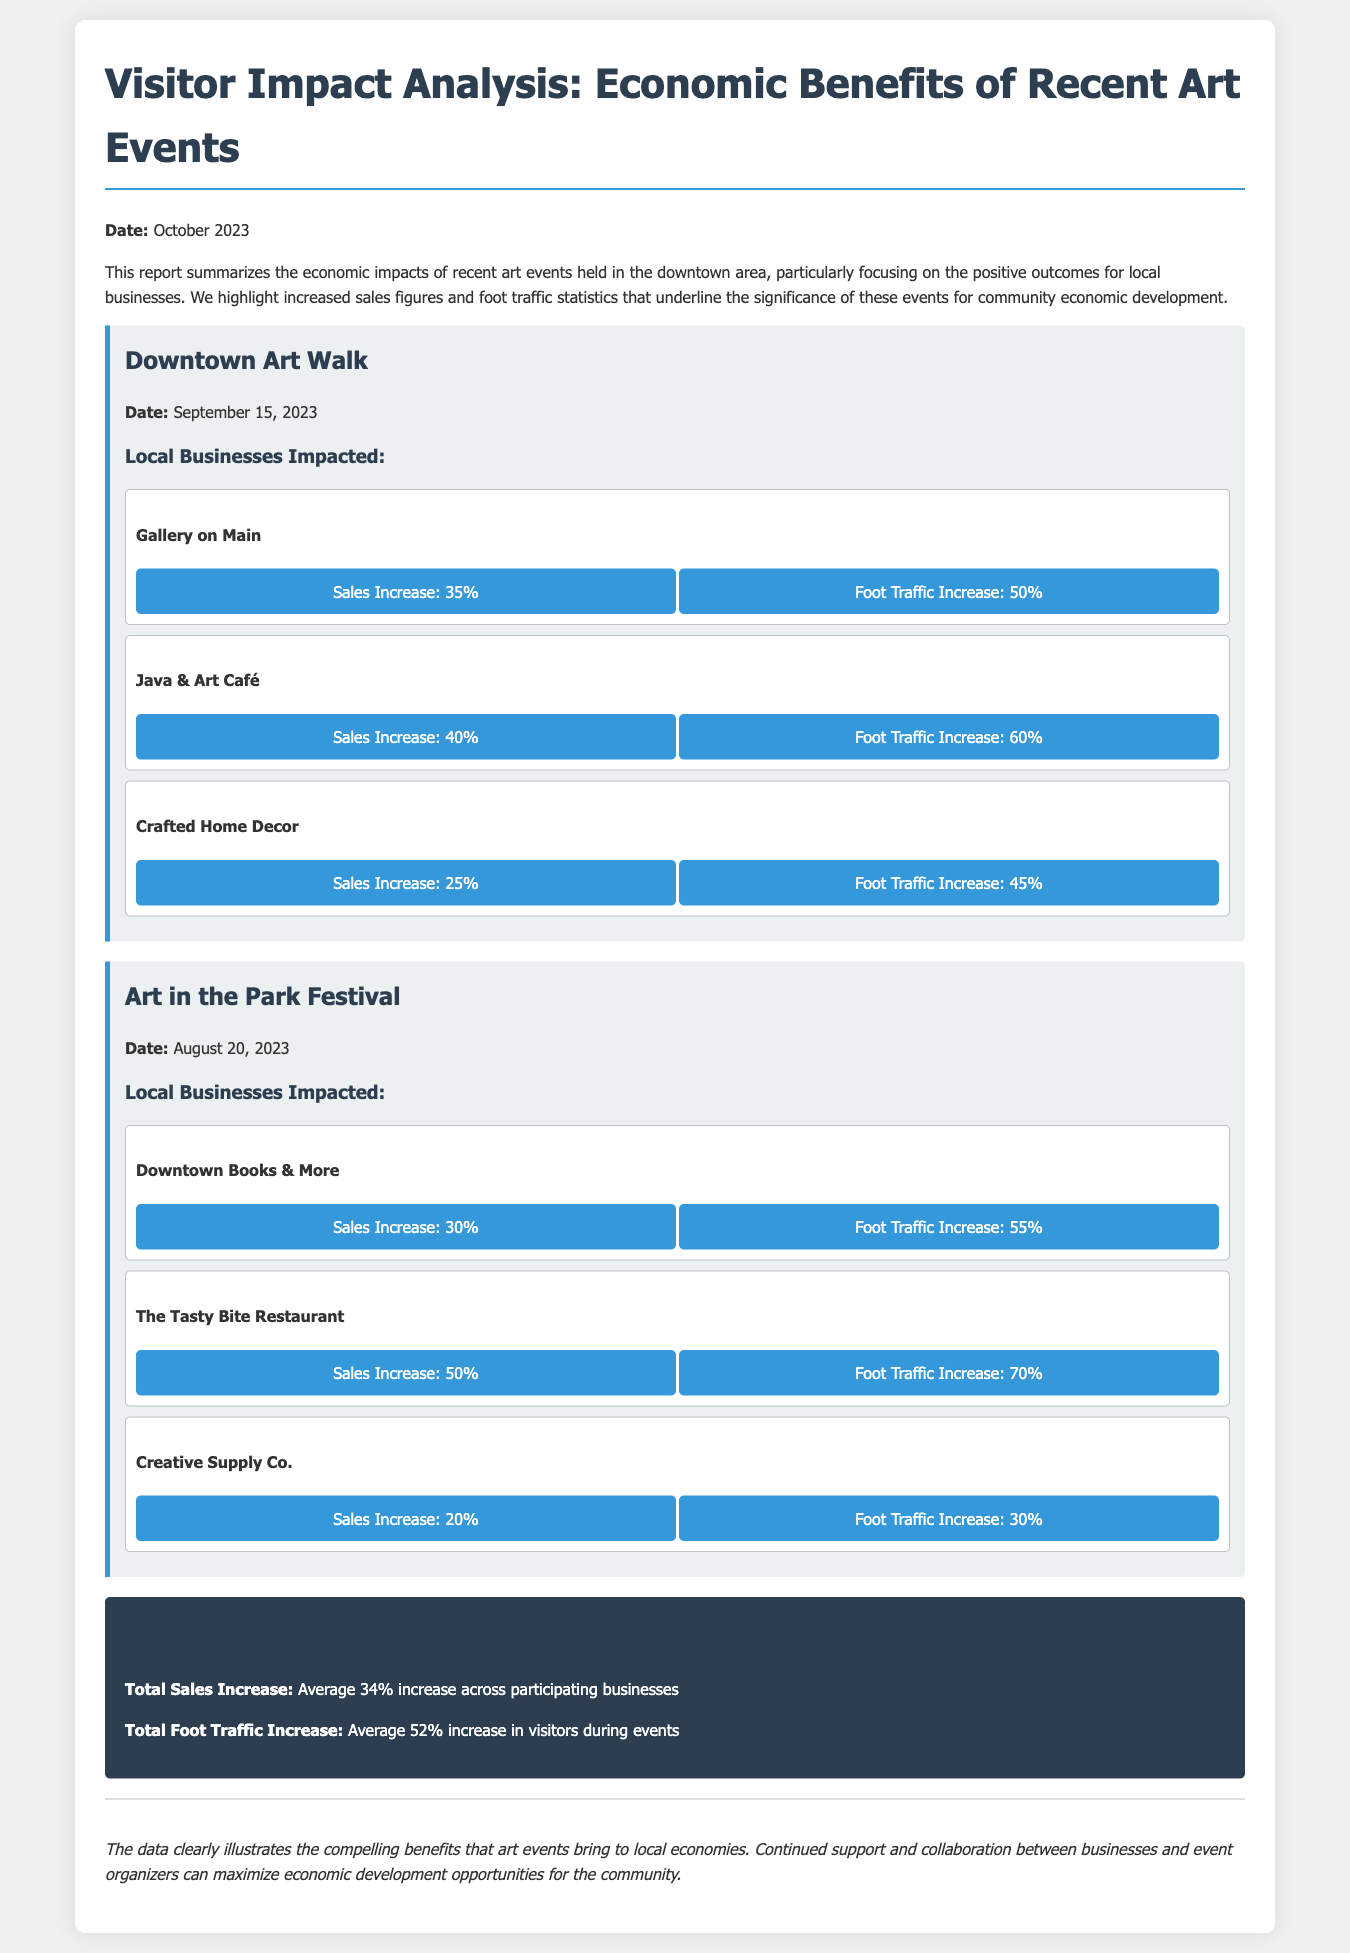What event took place on September 15, 2023? The event held on September 15, 2023, was the Downtown Art Walk.
Answer: Downtown Art Walk What was the sales increase percentage for Java & Art Café? The sales increase for Java & Art Café was 40%.
Answer: 40% What is the average foot traffic increase across all participating businesses? The average foot traffic increase across all participating businesses is 52%.
Answer: 52% Which business experienced the highest sales increase during the Art in the Park Festival? The Tasty Bite Restaurant had the highest sales increase at 50%.
Answer: The Tasty Bite Restaurant What is the total sales increase reported across participating businesses? The total sales increase reported across participating businesses is an average of 34%.
Answer: 34% How many local businesses were impacted during the Downtown Art Walk? Three local businesses were impacted during the Downtown Art Walk.
Answer: Three What type of report is this document? This document is a Visitor Impact Analysis report.
Answer: Visitor Impact Analysis What is emphasized as a crucial outcome of the art events in the conclusion? The conclusion emphasizes continued support and collaboration between businesses and event organizers.
Answer: Continued support and collaboration 